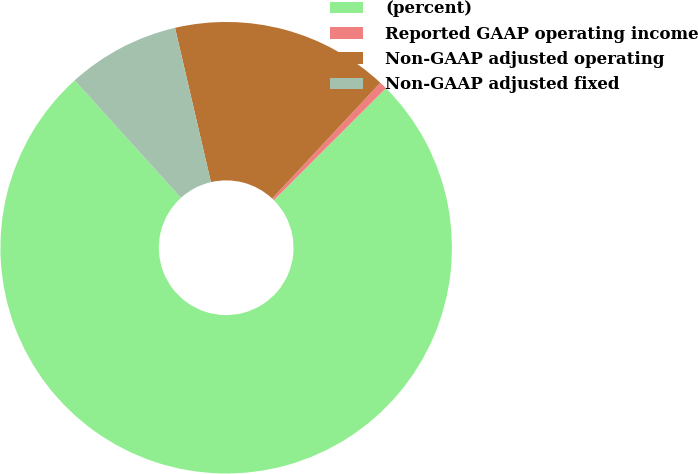Convert chart. <chart><loc_0><loc_0><loc_500><loc_500><pie_chart><fcel>(percent)<fcel>Reported GAAP operating income<fcel>Non-GAAP adjusted operating<fcel>Non-GAAP adjusted fixed<nl><fcel>75.78%<fcel>0.55%<fcel>15.6%<fcel>8.07%<nl></chart> 